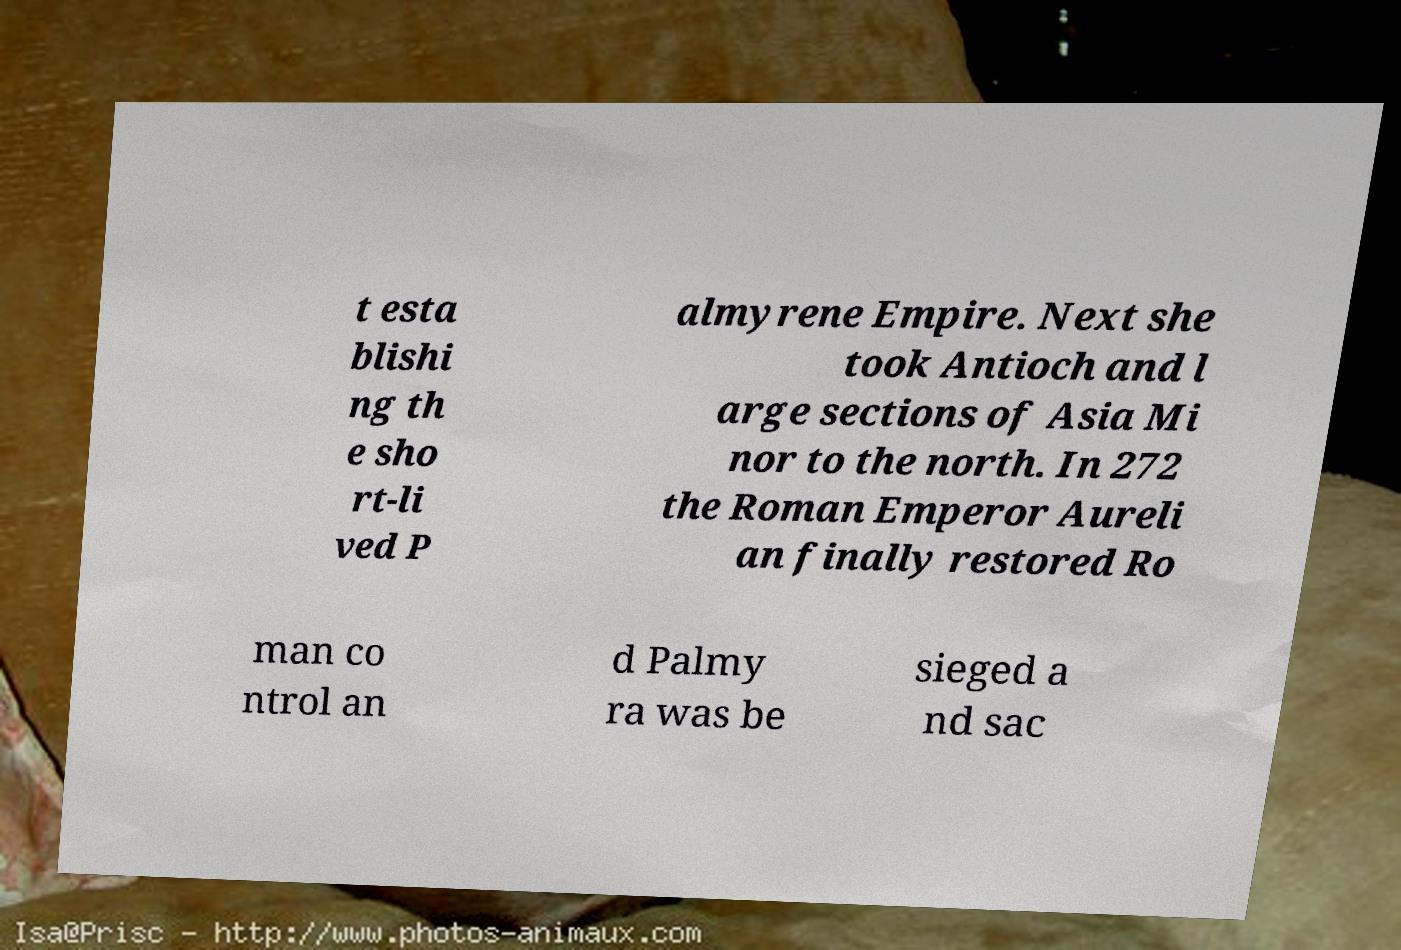What messages or text are displayed in this image? I need them in a readable, typed format. t esta blishi ng th e sho rt-li ved P almyrene Empire. Next she took Antioch and l arge sections of Asia Mi nor to the north. In 272 the Roman Emperor Aureli an finally restored Ro man co ntrol an d Palmy ra was be sieged a nd sac 